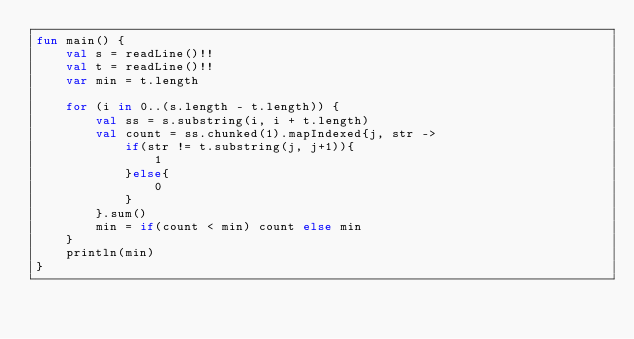<code> <loc_0><loc_0><loc_500><loc_500><_Kotlin_>fun main() {
    val s = readLine()!!
    val t = readLine()!!
    var min = t.length

    for (i in 0..(s.length - t.length)) {
        val ss = s.substring(i, i + t.length)
        val count = ss.chunked(1).mapIndexed{j, str ->
            if(str != t.substring(j, j+1)){
                1
            }else{
                0
            }
        }.sum()
        min = if(count < min) count else min
    }
    println(min)
}</code> 